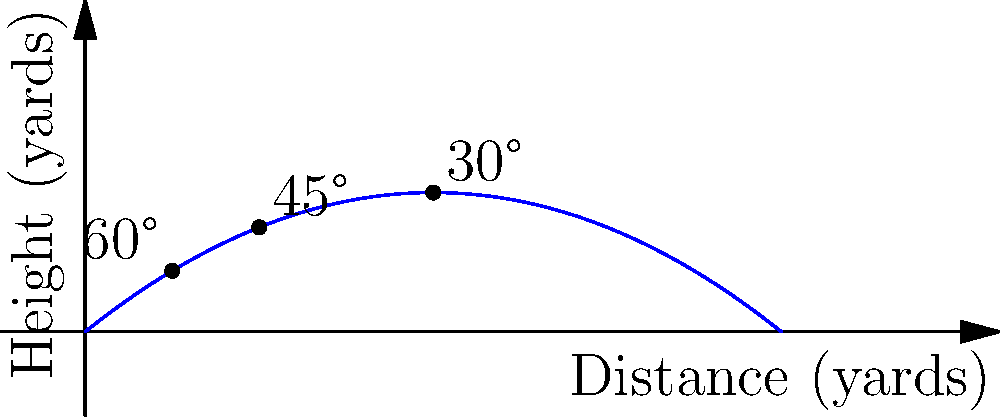Your son is practicing his football kicks, and you want to help him understand the best angle for kicking. Looking at the trajectory graph, which angle appears to result in the longest kick distance? To understand the optimal angle for kicking a football, let's break down the graph:

1. The graph shows three different trajectories, each representing a kick at a different angle.

2. The x-axis represents the distance the ball travels horizontally, while the y-axis shows the height the ball reaches.

3. We can see three different paths:
   - A steep curve labeled 60°
   - A medium curve labeled 45°
   - A flatter curve labeled 30°

4. In physics, we learn that for projectile motion (like kicking a football), the optimal angle to achieve maximum distance is actually 45°. This is because it provides the best balance between vertical and horizontal velocity.

5. Looking at the graph, we can confirm this:
   - The 60° kick goes high but doesn't travel as far horizontally.
   - The 30° kick stays low and doesn't reach as far.
   - The 45° kick achieves the greatest horizontal distance.

6. The 45° trajectory reaches the farthest point along the x-axis before coming back down, indicating it travels the longest distance.

Therefore, based on this graph and the principles of projectile motion, the 45° angle appears to result in the longest kick distance.
Answer: 45° 